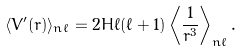Convert formula to latex. <formula><loc_0><loc_0><loc_500><loc_500>\langle V ^ { \prime } ( r ) \rangle _ { n \ell } = 2 H \ell ( \ell + 1 ) \left \langle \frac { 1 } { r ^ { 3 } } \right \rangle _ { n \ell } .</formula> 